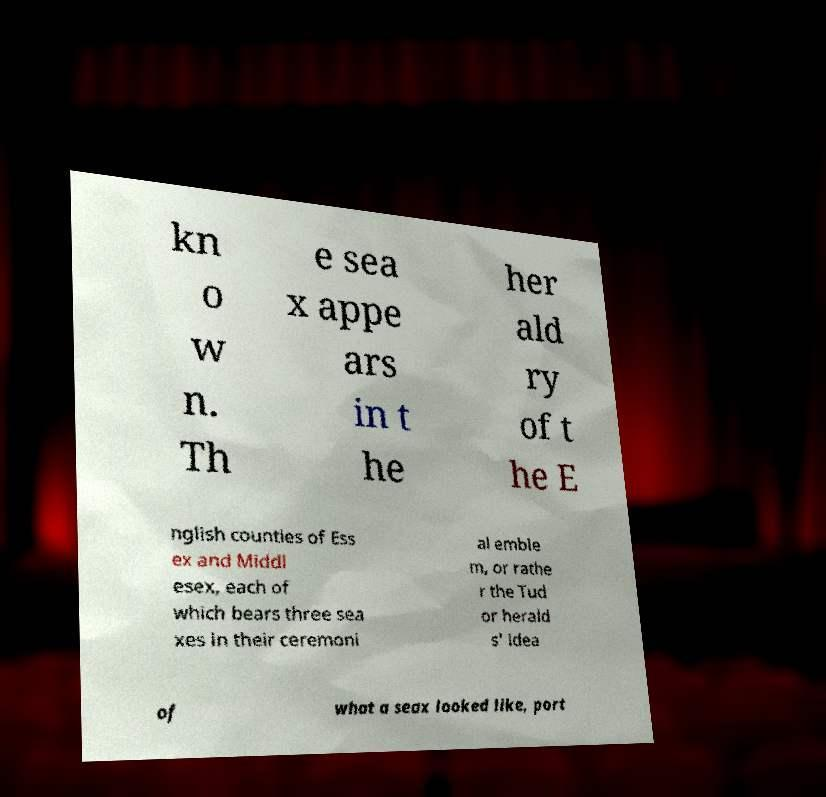Can you accurately transcribe the text from the provided image for me? kn o w n. Th e sea x appe ars in t he her ald ry of t he E nglish counties of Ess ex and Middl esex, each of which bears three sea xes in their ceremoni al emble m, or rathe r the Tud or herald s' idea of what a seax looked like, port 